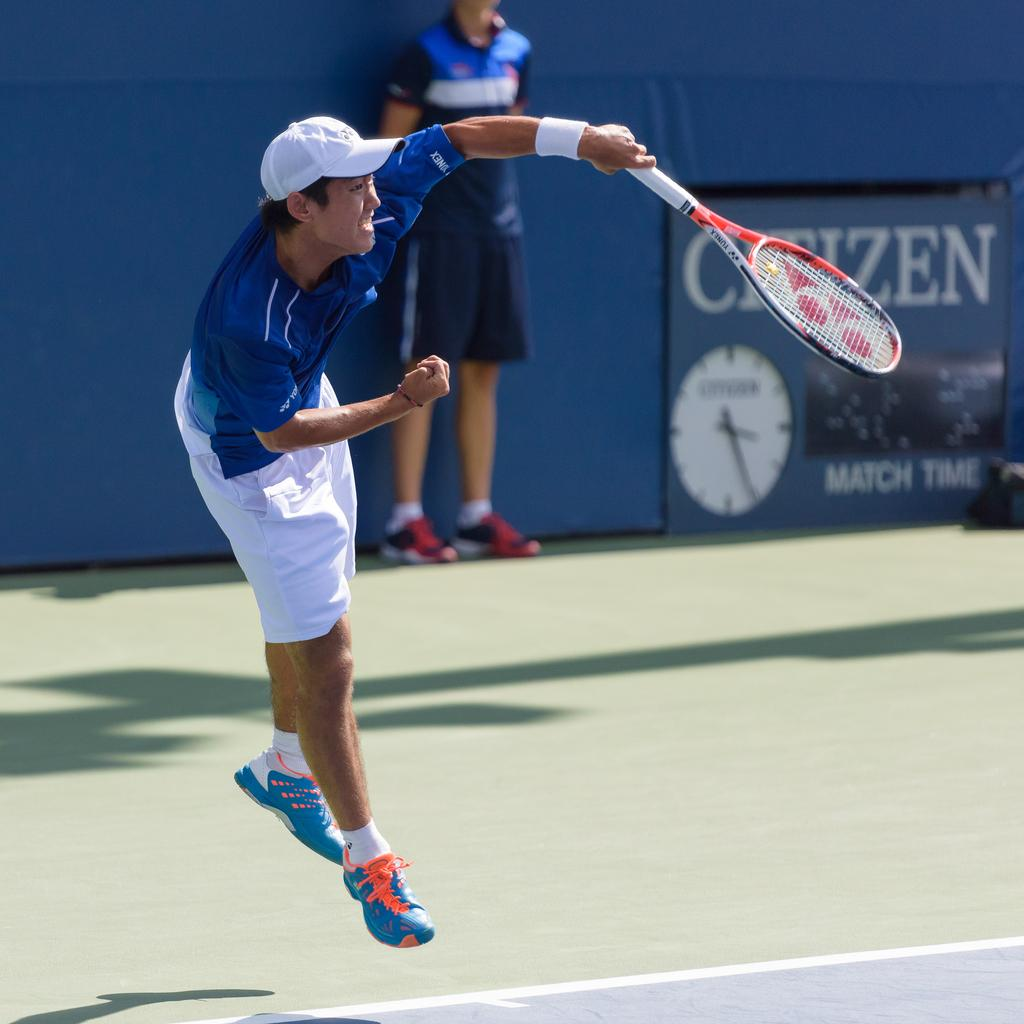Who is the main subject in the image? There is a man in the image. What is the man doing in the image? The man is jumping. What object is the man holding in the image? The man is holding a tennis racket. Can you describe the background of the image? There is another person in the background of the image, and the background includes a hoarding. What arithmetic problem is the man solving in the image? There is no arithmetic problem present in the image; the man is jumping while holding a tennis racket. What type of glove is the man wearing in the image? The man is not wearing a glove in the image; he is holding a tennis racket. 